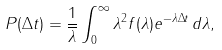Convert formula to latex. <formula><loc_0><loc_0><loc_500><loc_500>P ( \Delta t ) = \frac { 1 } { \overline { \lambda } } \int _ { 0 } ^ { \infty } \lambda ^ { 2 } f ( \lambda ) e ^ { - \lambda \Delta t } \, d \lambda ,</formula> 